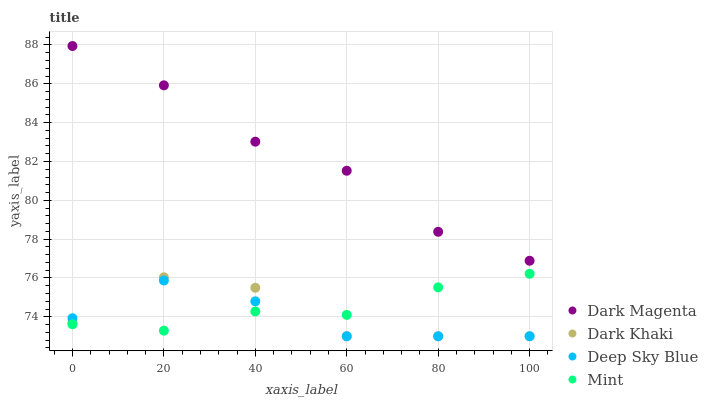Does Deep Sky Blue have the minimum area under the curve?
Answer yes or no. Yes. Does Dark Magenta have the maximum area under the curve?
Answer yes or no. Yes. Does Mint have the minimum area under the curve?
Answer yes or no. No. Does Mint have the maximum area under the curve?
Answer yes or no. No. Is Mint the smoothest?
Answer yes or no. Yes. Is Dark Khaki the roughest?
Answer yes or no. Yes. Is Dark Magenta the smoothest?
Answer yes or no. No. Is Dark Magenta the roughest?
Answer yes or no. No. Does Dark Khaki have the lowest value?
Answer yes or no. Yes. Does Mint have the lowest value?
Answer yes or no. No. Does Dark Magenta have the highest value?
Answer yes or no. Yes. Does Mint have the highest value?
Answer yes or no. No. Is Mint less than Dark Magenta?
Answer yes or no. Yes. Is Dark Magenta greater than Dark Khaki?
Answer yes or no. Yes. Does Mint intersect Deep Sky Blue?
Answer yes or no. Yes. Is Mint less than Deep Sky Blue?
Answer yes or no. No. Is Mint greater than Deep Sky Blue?
Answer yes or no. No. Does Mint intersect Dark Magenta?
Answer yes or no. No. 